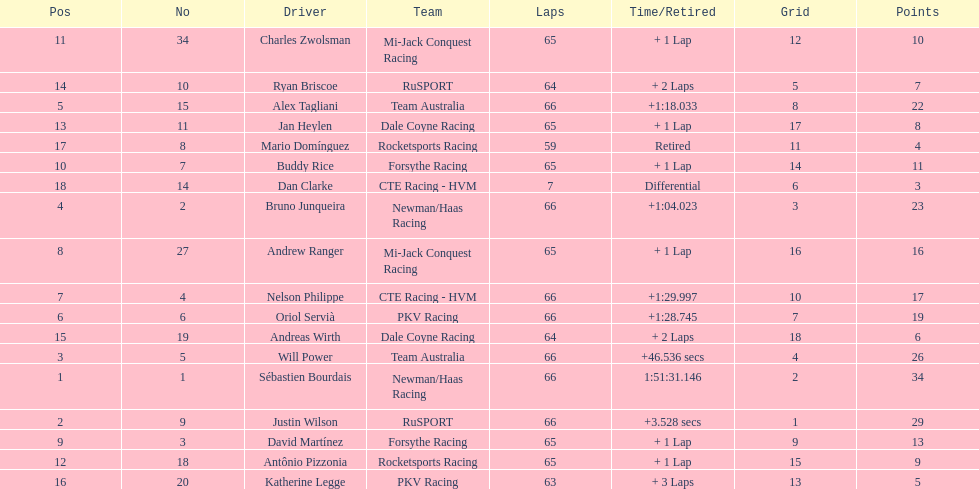Which drivers scored at least 10 points? Sébastien Bourdais, Justin Wilson, Will Power, Bruno Junqueira, Alex Tagliani, Oriol Servià, Nelson Philippe, Andrew Ranger, David Martínez, Buddy Rice, Charles Zwolsman. Parse the table in full. {'header': ['Pos', 'No', 'Driver', 'Team', 'Laps', 'Time/Retired', 'Grid', 'Points'], 'rows': [['11', '34', 'Charles Zwolsman', 'Mi-Jack Conquest Racing', '65', '+ 1 Lap', '12', '10'], ['14', '10', 'Ryan Briscoe', 'RuSPORT', '64', '+ 2 Laps', '5', '7'], ['5', '15', 'Alex Tagliani', 'Team Australia', '66', '+1:18.033', '8', '22'], ['13', '11', 'Jan Heylen', 'Dale Coyne Racing', '65', '+ 1 Lap', '17', '8'], ['17', '8', 'Mario Domínguez', 'Rocketsports Racing', '59', 'Retired', '11', '4'], ['10', '7', 'Buddy Rice', 'Forsythe Racing', '65', '+ 1 Lap', '14', '11'], ['18', '14', 'Dan Clarke', 'CTE Racing - HVM', '7', 'Differential', '6', '3'], ['4', '2', 'Bruno Junqueira', 'Newman/Haas Racing', '66', '+1:04.023', '3', '23'], ['8', '27', 'Andrew Ranger', 'Mi-Jack Conquest Racing', '65', '+ 1 Lap', '16', '16'], ['7', '4', 'Nelson Philippe', 'CTE Racing - HVM', '66', '+1:29.997', '10', '17'], ['6', '6', 'Oriol Servià', 'PKV Racing', '66', '+1:28.745', '7', '19'], ['15', '19', 'Andreas Wirth', 'Dale Coyne Racing', '64', '+ 2 Laps', '18', '6'], ['3', '5', 'Will Power', 'Team Australia', '66', '+46.536 secs', '4', '26'], ['1', '1', 'Sébastien Bourdais', 'Newman/Haas Racing', '66', '1:51:31.146', '2', '34'], ['2', '9', 'Justin Wilson', 'RuSPORT', '66', '+3.528 secs', '1', '29'], ['9', '3', 'David Martínez', 'Forsythe Racing', '65', '+ 1 Lap', '9', '13'], ['12', '18', 'Antônio Pizzonia', 'Rocketsports Racing', '65', '+ 1 Lap', '15', '9'], ['16', '20', 'Katherine Legge', 'PKV Racing', '63', '+ 3 Laps', '13', '5']]} Of those drivers, which ones scored at least 20 points? Sébastien Bourdais, Justin Wilson, Will Power, Bruno Junqueira, Alex Tagliani. Of those 5, which driver scored the most points? Sébastien Bourdais. 